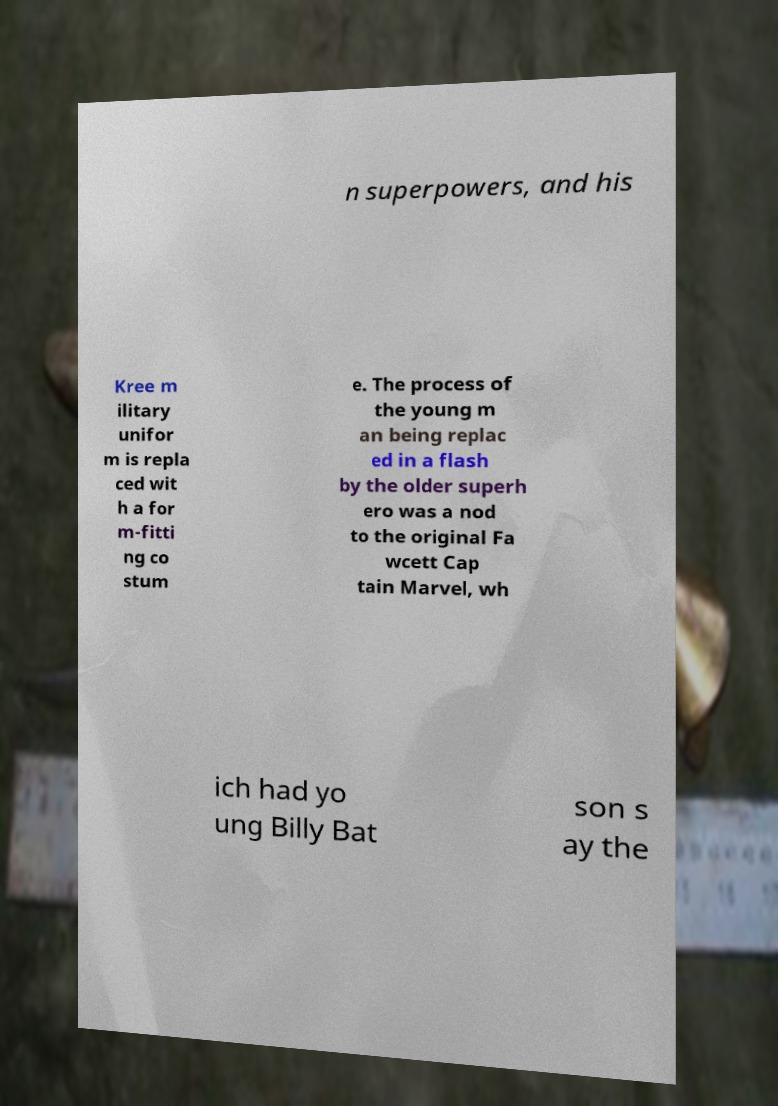There's text embedded in this image that I need extracted. Can you transcribe it verbatim? n superpowers, and his Kree m ilitary unifor m is repla ced wit h a for m-fitti ng co stum e. The process of the young m an being replac ed in a flash by the older superh ero was a nod to the original Fa wcett Cap tain Marvel, wh ich had yo ung Billy Bat son s ay the 